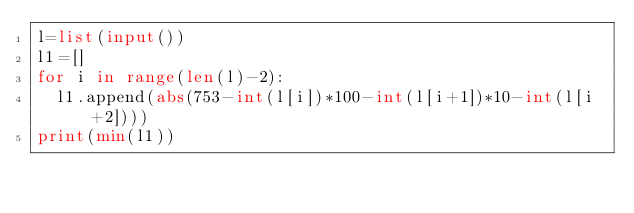<code> <loc_0><loc_0><loc_500><loc_500><_Python_>l=list(input())
l1=[]
for i in range(len(l)-2):
  l1.append(abs(753-int(l[i])*100-int(l[i+1])*10-int(l[i+2])))
print(min(l1))

  
  </code> 